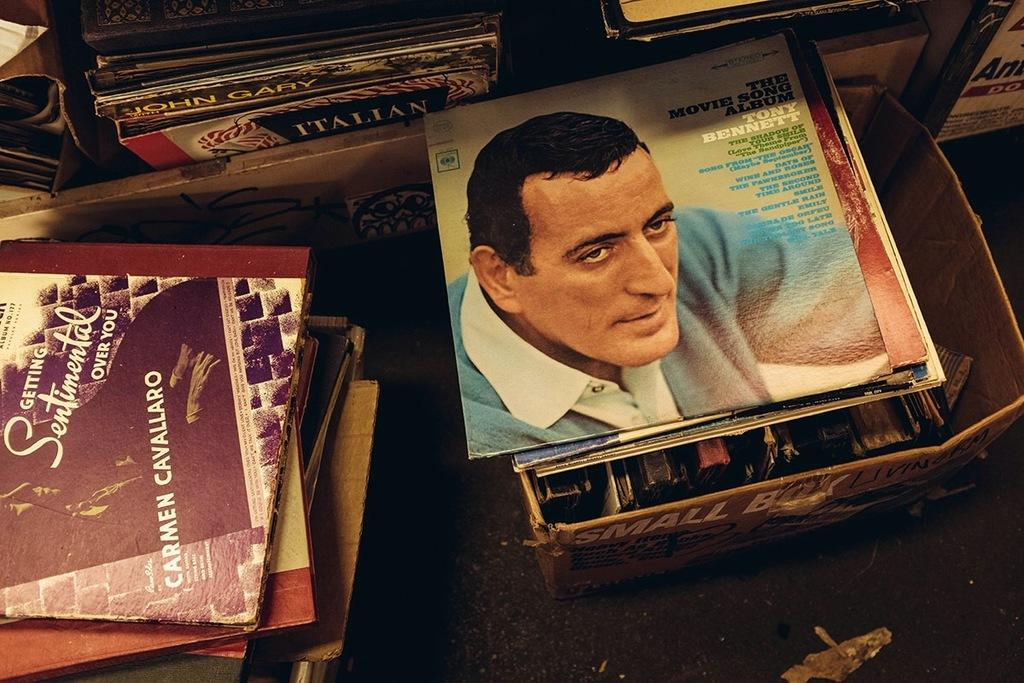<image>
Describe the image concisely. A Tony Bennett record album cover shows Tony's face. 